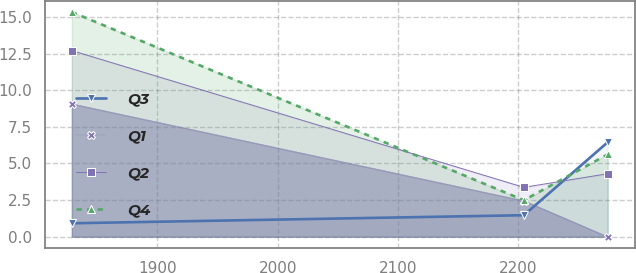Convert chart. <chart><loc_0><loc_0><loc_500><loc_500><line_chart><ecel><fcel>Q3<fcel>Q1<fcel>Q2<fcel>Q4<nl><fcel>1828.92<fcel>0.92<fcel>9.07<fcel>12.7<fcel>15.33<nl><fcel>2204.52<fcel>1.47<fcel>2.46<fcel>3.37<fcel>2.49<nl><fcel>2274.19<fcel>6.45<fcel>0<fcel>4.3<fcel>5.62<nl></chart> 